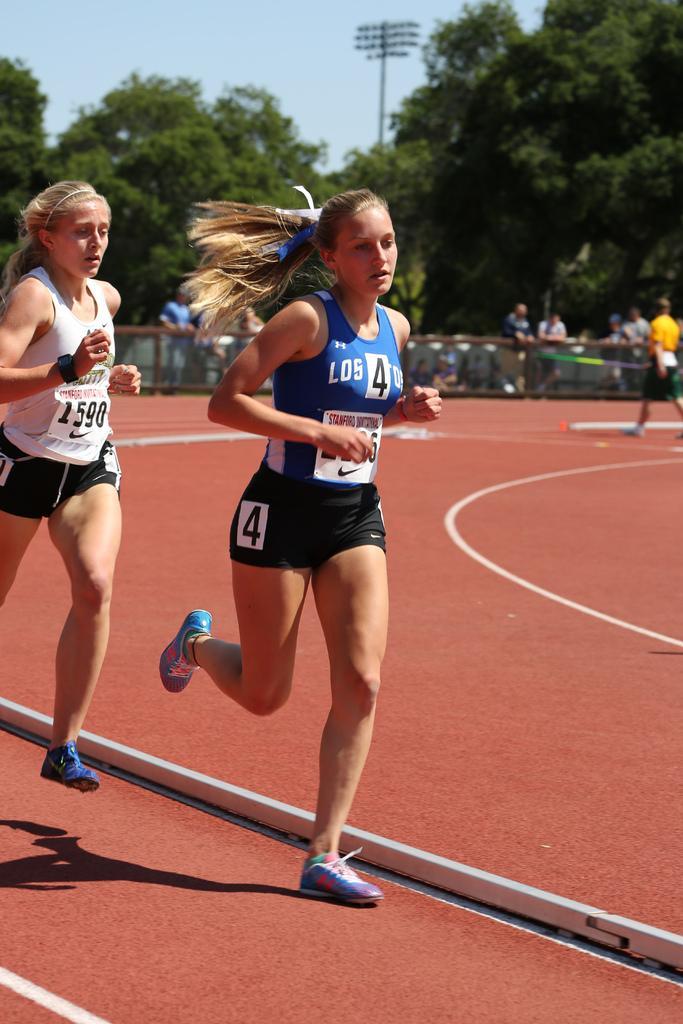Describe this image in one or two sentences. In the picture we can see two women are running on the running surface and they are wearing a sportswear and shoes and in the background, we can see a fencing wall behind it, we can see some people standing and we can also see some trees and a sky. 